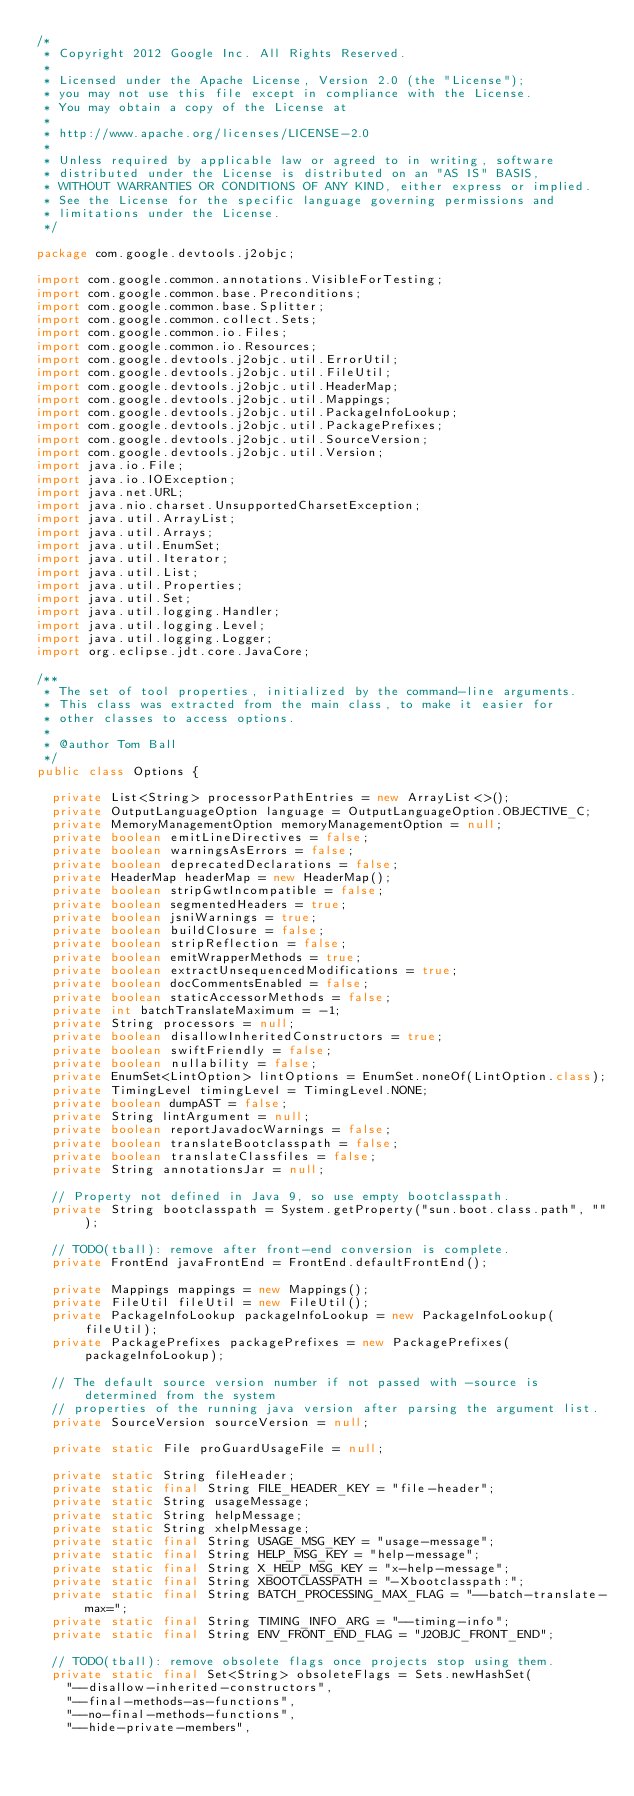Convert code to text. <code><loc_0><loc_0><loc_500><loc_500><_Java_>/*
 * Copyright 2012 Google Inc. All Rights Reserved.
 *
 * Licensed under the Apache License, Version 2.0 (the "License");
 * you may not use this file except in compliance with the License.
 * You may obtain a copy of the License at
 *
 * http://www.apache.org/licenses/LICENSE-2.0
 *
 * Unless required by applicable law or agreed to in writing, software
 * distributed under the License is distributed on an "AS IS" BASIS,
 * WITHOUT WARRANTIES OR CONDITIONS OF ANY KIND, either express or implied.
 * See the License for the specific language governing permissions and
 * limitations under the License.
 */

package com.google.devtools.j2objc;

import com.google.common.annotations.VisibleForTesting;
import com.google.common.base.Preconditions;
import com.google.common.base.Splitter;
import com.google.common.collect.Sets;
import com.google.common.io.Files;
import com.google.common.io.Resources;
import com.google.devtools.j2objc.util.ErrorUtil;
import com.google.devtools.j2objc.util.FileUtil;
import com.google.devtools.j2objc.util.HeaderMap;
import com.google.devtools.j2objc.util.Mappings;
import com.google.devtools.j2objc.util.PackageInfoLookup;
import com.google.devtools.j2objc.util.PackagePrefixes;
import com.google.devtools.j2objc.util.SourceVersion;
import com.google.devtools.j2objc.util.Version;
import java.io.File;
import java.io.IOException;
import java.net.URL;
import java.nio.charset.UnsupportedCharsetException;
import java.util.ArrayList;
import java.util.Arrays;
import java.util.EnumSet;
import java.util.Iterator;
import java.util.List;
import java.util.Properties;
import java.util.Set;
import java.util.logging.Handler;
import java.util.logging.Level;
import java.util.logging.Logger;
import org.eclipse.jdt.core.JavaCore;

/**
 * The set of tool properties, initialized by the command-line arguments.
 * This class was extracted from the main class, to make it easier for
 * other classes to access options.
 *
 * @author Tom Ball
 */
public class Options {

  private List<String> processorPathEntries = new ArrayList<>();
  private OutputLanguageOption language = OutputLanguageOption.OBJECTIVE_C;
  private MemoryManagementOption memoryManagementOption = null;
  private boolean emitLineDirectives = false;
  private boolean warningsAsErrors = false;
  private boolean deprecatedDeclarations = false;
  private HeaderMap headerMap = new HeaderMap();
  private boolean stripGwtIncompatible = false;
  private boolean segmentedHeaders = true;
  private boolean jsniWarnings = true;
  private boolean buildClosure = false;
  private boolean stripReflection = false;
  private boolean emitWrapperMethods = true;
  private boolean extractUnsequencedModifications = true;
  private boolean docCommentsEnabled = false;
  private boolean staticAccessorMethods = false;
  private int batchTranslateMaximum = -1;
  private String processors = null;
  private boolean disallowInheritedConstructors = true;
  private boolean swiftFriendly = false;
  private boolean nullability = false;
  private EnumSet<LintOption> lintOptions = EnumSet.noneOf(LintOption.class);
  private TimingLevel timingLevel = TimingLevel.NONE;
  private boolean dumpAST = false;
  private String lintArgument = null;
  private boolean reportJavadocWarnings = false;
  private boolean translateBootclasspath = false;
  private boolean translateClassfiles = false;
  private String annotationsJar = null;

  // Property not defined in Java 9, so use empty bootclasspath.
  private String bootclasspath = System.getProperty("sun.boot.class.path", "");

  // TODO(tball): remove after front-end conversion is complete.
  private FrontEnd javaFrontEnd = FrontEnd.defaultFrontEnd();

  private Mappings mappings = new Mappings();
  private FileUtil fileUtil = new FileUtil();
  private PackageInfoLookup packageInfoLookup = new PackageInfoLookup(fileUtil);
  private PackagePrefixes packagePrefixes = new PackagePrefixes(packageInfoLookup);

  // The default source version number if not passed with -source is determined from the system
  // properties of the running java version after parsing the argument list.
  private SourceVersion sourceVersion = null;

  private static File proGuardUsageFile = null;

  private static String fileHeader;
  private static final String FILE_HEADER_KEY = "file-header";
  private static String usageMessage;
  private static String helpMessage;
  private static String xhelpMessage;
  private static final String USAGE_MSG_KEY = "usage-message";
  private static final String HELP_MSG_KEY = "help-message";
  private static final String X_HELP_MSG_KEY = "x-help-message";
  private static final String XBOOTCLASSPATH = "-Xbootclasspath:";
  private static final String BATCH_PROCESSING_MAX_FLAG = "--batch-translate-max=";
  private static final String TIMING_INFO_ARG = "--timing-info";
  private static final String ENV_FRONT_END_FLAG = "J2OBJC_FRONT_END";

  // TODO(tball): remove obsolete flags once projects stop using them.
  private static final Set<String> obsoleteFlags = Sets.newHashSet(
    "--disallow-inherited-constructors",
    "--final-methods-as-functions",
    "--no-final-methods-functions",
    "--hide-private-members",</code> 